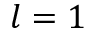Convert formula to latex. <formula><loc_0><loc_0><loc_500><loc_500>l = 1</formula> 